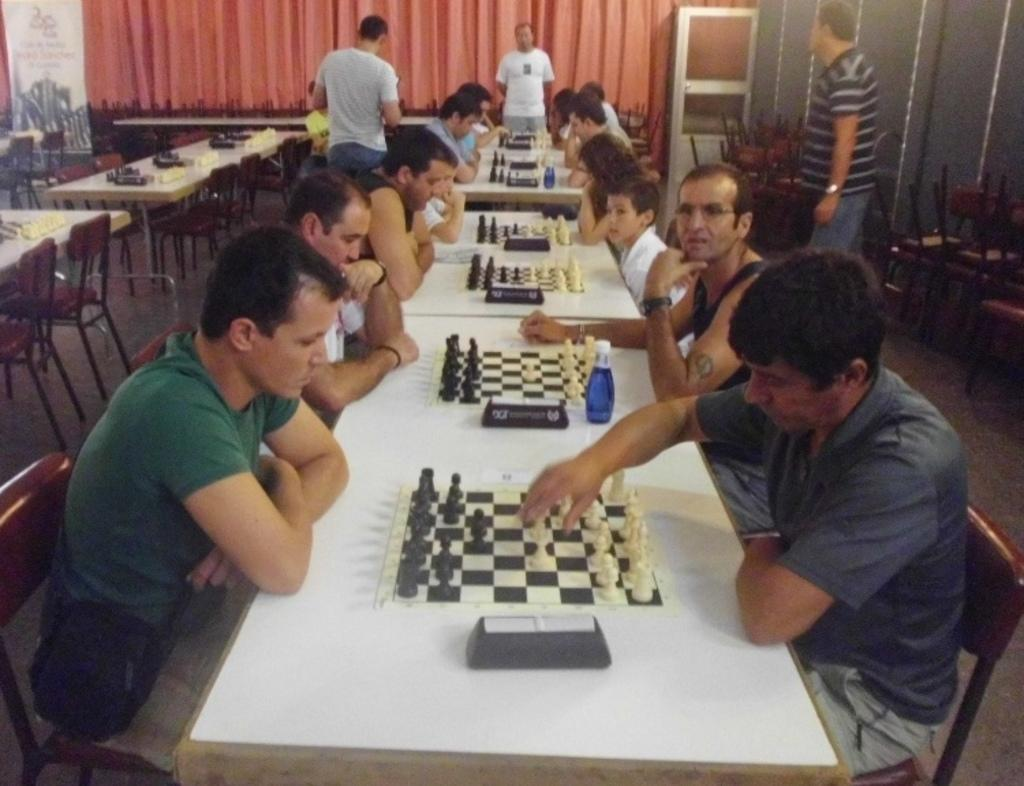What are the persons in the image doing? The group of persons in the image are playing chess. Can you describe any additional features in the image? Yes, there is a banner on the left side of the image. What color is the sheet visible in the background of the image? The sheet in the background of the image is red. What type of impulse can be seen affecting the chess pieces in the image? There is no impulse affecting the chess pieces in the image; they are being moved by the players. Can you describe the air quality in the image? The image does not provide any information about the air quality. 